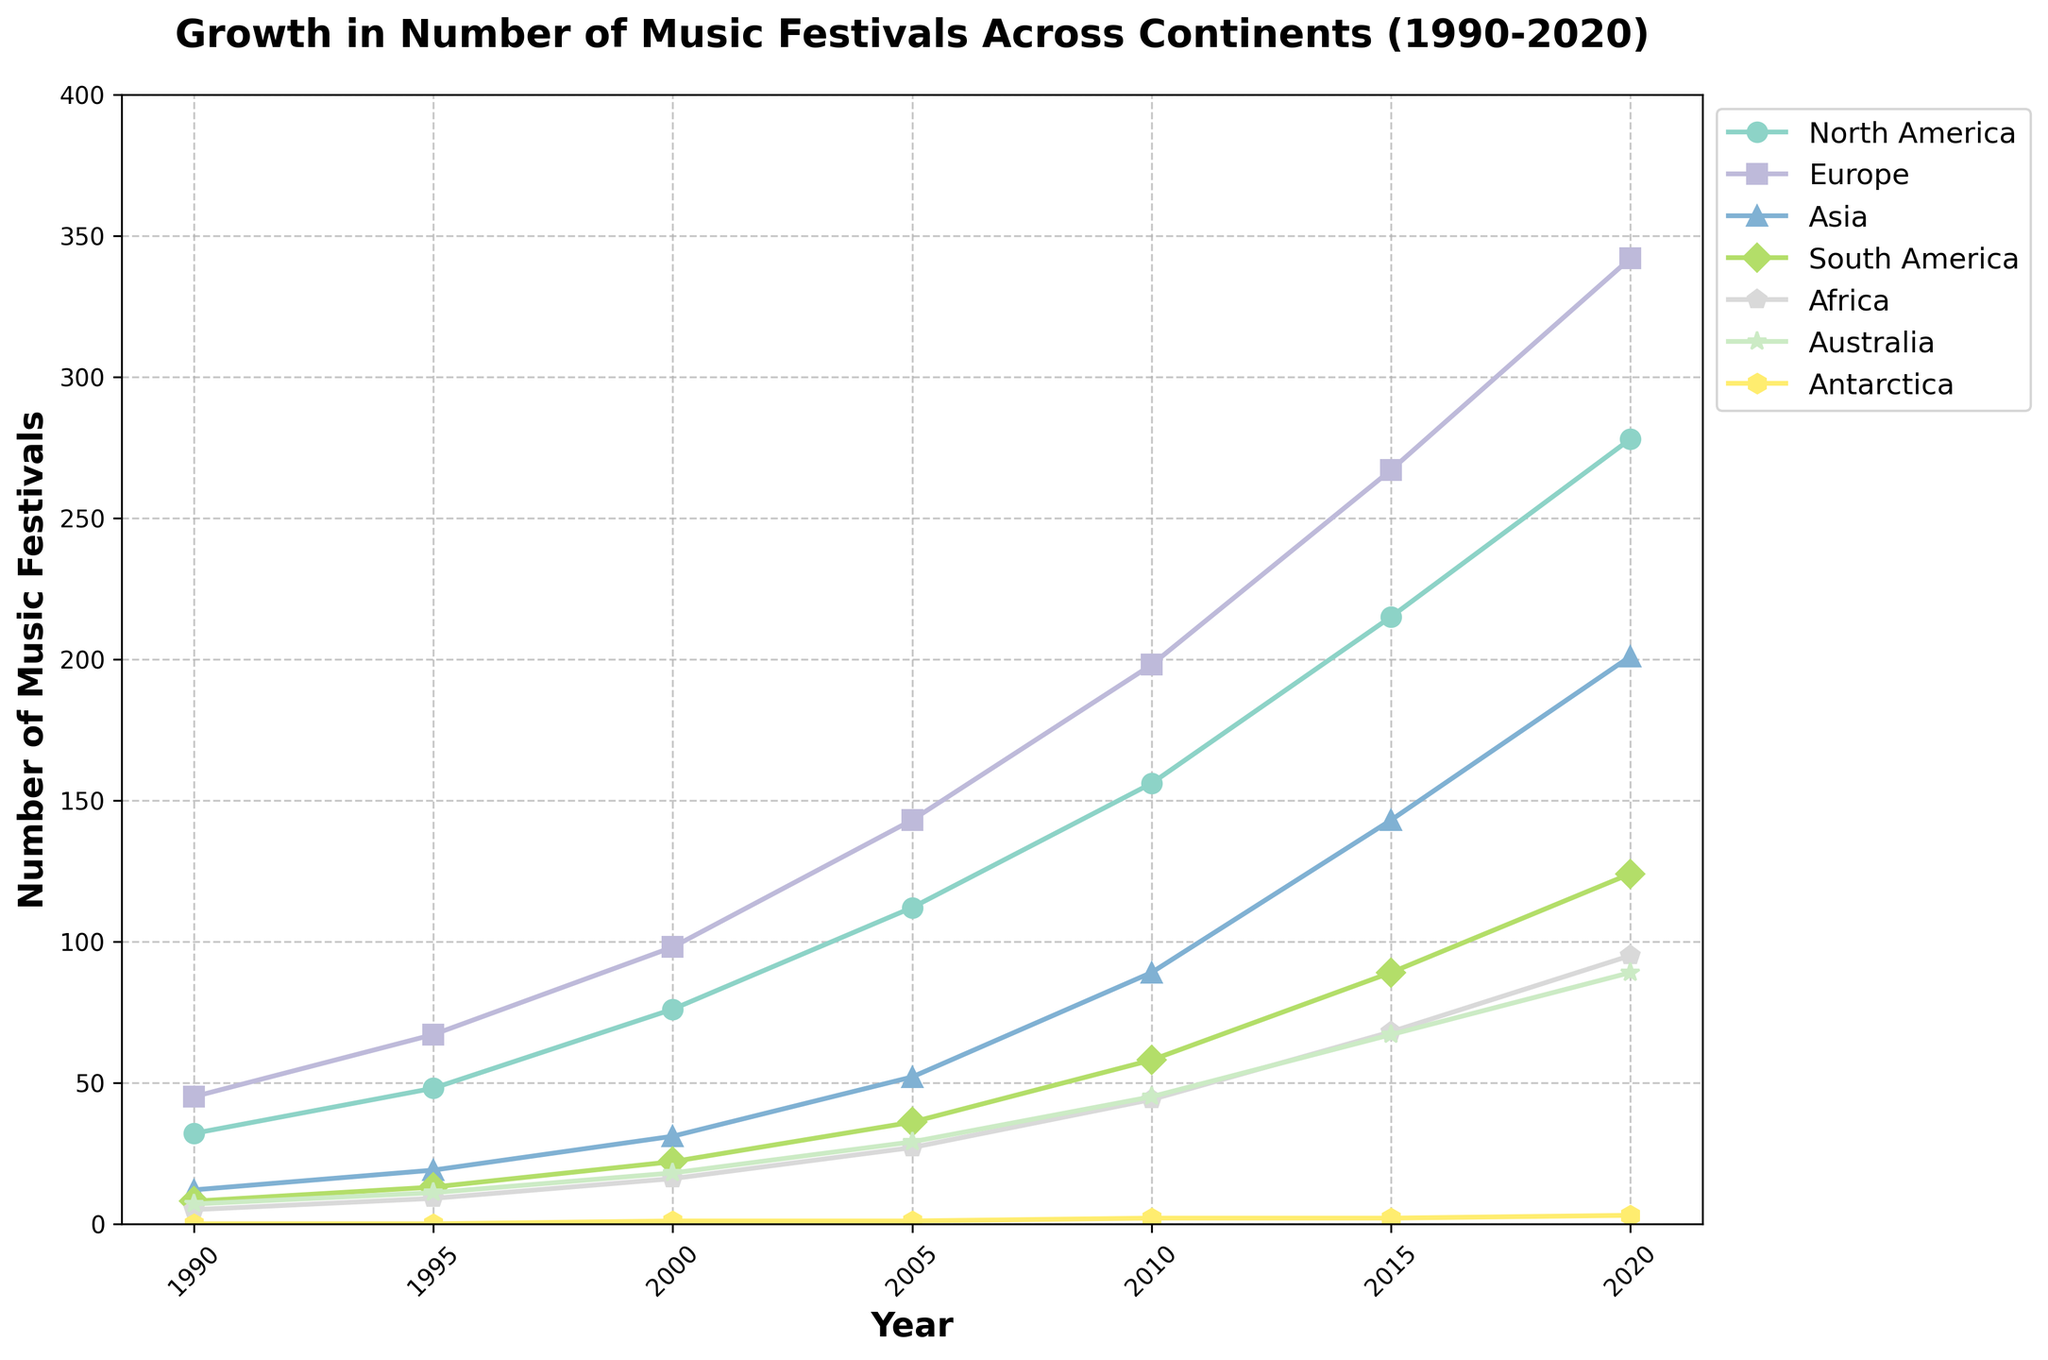What is the overall trend in the number of music festivals in Europe from 1990 to 2020? To determine the trend in the number of music festivals in Europe, examine the line representing Europe, marked by its color and typically identified by a label in the legend. The line starts at 45 in 1990 and ends at 342 in 2020 with a steady upward slope, indicating consistent growth.
Answer: Consistent growth Which continent had the highest number of music festivals in 2020? To identify the continent with the highest number of festivals in 2020, look at the data points at the year 2020 on the x-axis. The line that reaches the highest point on the y-axis represents the continent with the most festivals. Europe has the highest point at 342.
Answer: Europe How many more music festivals were there in North America in 2000 compared to Asia in 2000? Subtract the number of festivals in Asia from the number in North America for the year 2000. North America: 76, Asia: 31. The difference is 76 - 31 = 45.
Answer: 45 Which continent shows the least variability in the number of music festivals over the years? Variability is observed through fluctuations or steady lines. The line for Antarctica is nearly flat, with values of 0, 1, 1, 2, 2, and 3 over the years, indicating the least variability.
Answer: Antarctica What is the average number of music festivals in Australia from 1990 to 2020? The average is found by summing the values and dividing by the number of years. Sum of Australia's values: 7 + 11 + 18 + 29 + 45 + 67 + 89 = 266, and there are 7 data points. The average is 266 / 7 = 38.
Answer: 38 By what factor has the number of music festivals in Africa increased from 1990 to 2020? Divide the 2020 value by the 1990 value. Africa: 2020 is 95, 1990 is 5. 95 / 5 = 19.
Answer: 19 Which year shows the most significant increase in the number of music festivals in Asia compared to the previous recorded year? Identify the years with the most considerable differences by examining the line for Asia. The years between 2005 (52) and 2010 (89) show an increase of 37, the largest observed step.
Answer: 2005 to 2010 What is the difference in the number of music festivals between South America and Africa in 2015? Subtract the value for Africa from that of South America for the year 2015. South America: 89, Africa: 68. The difference is 89 - 68 = 21.
Answer: 21 In which continent did the number of music festivals remain practically unchanged around 2015 and 2020? Look for lines that remain almost flat between 2015 and 2020. Antarctica shows minimal change from 2 to 3 festivals, indicating relatively stable numbers.
Answer: Antarctica 